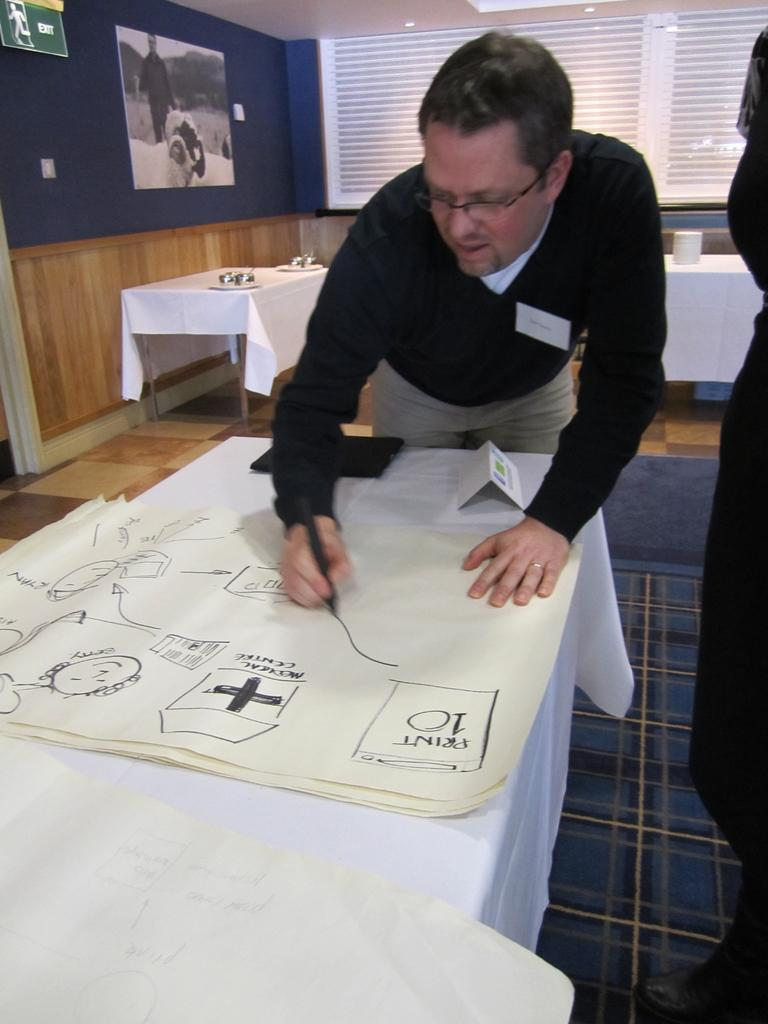What is the person in the image wearing? The person is wearing a black dress in the image. What is the person doing in the image? The person is drawing on a paper in the image. Where is the paper located? The paper is on a table in the image. Are there any other tables visible in the image? Yes, there are tables behind the person in the image. Is there anyone else present in the image? Yes, there is a person standing in the right corner of the image. What is the ladybug's opinion on the drawing in the image? There is no ladybug present in the image, so it is not possible to determine its opinion on the drawing. 